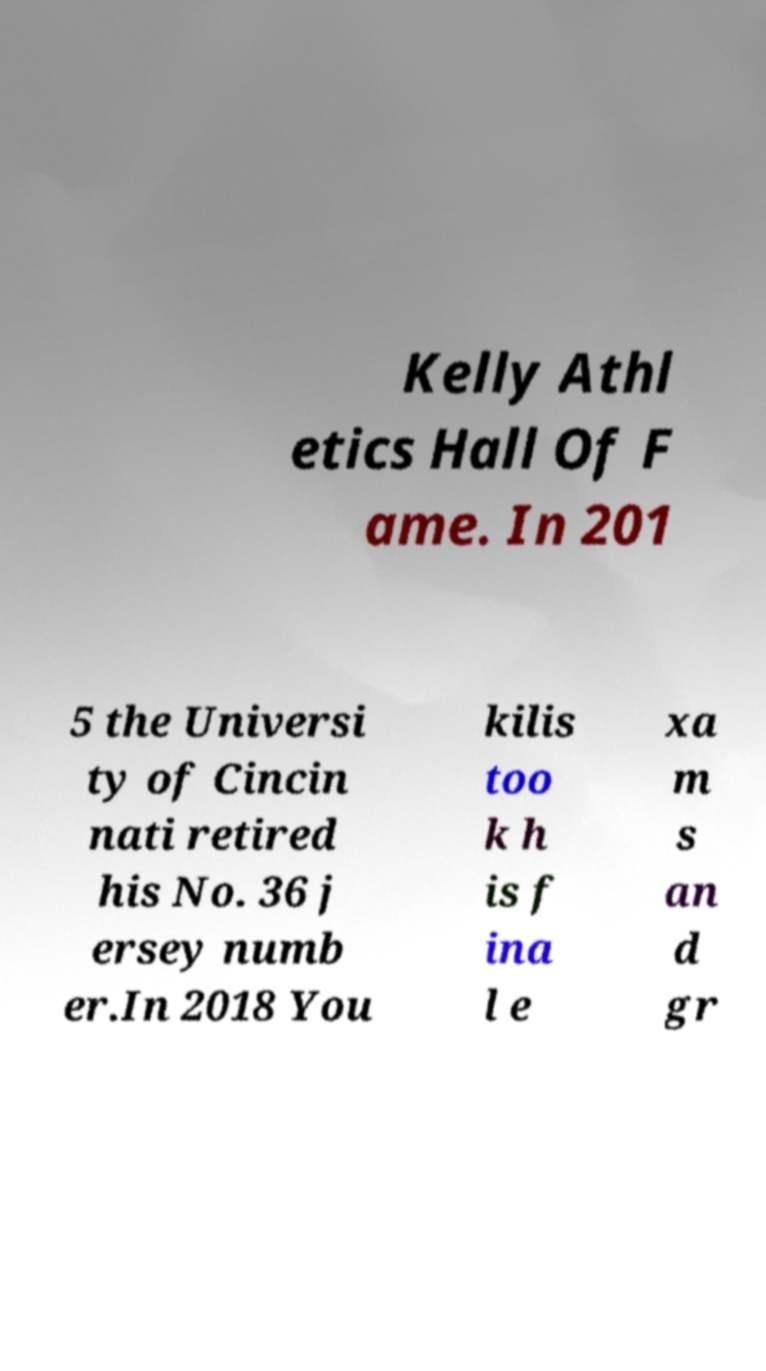Please identify and transcribe the text found in this image. Kelly Athl etics Hall Of F ame. In 201 5 the Universi ty of Cincin nati retired his No. 36 j ersey numb er.In 2018 You kilis too k h is f ina l e xa m s an d gr 